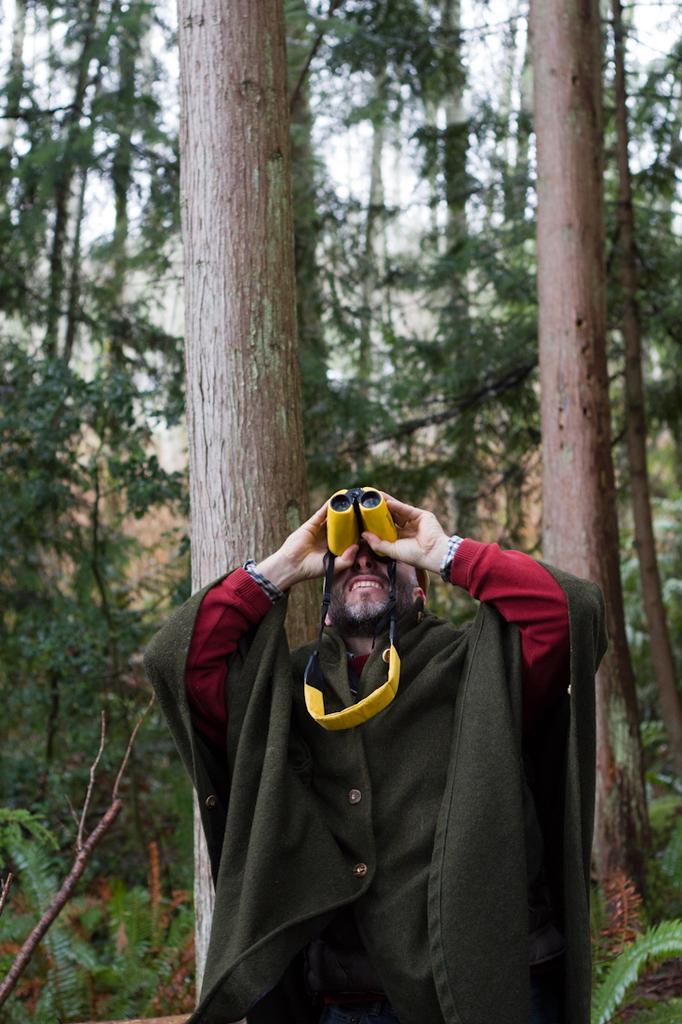Can you describe this image briefly? In this image there is a person standing and looking through the binoculars, behind him there are trees and plants. 